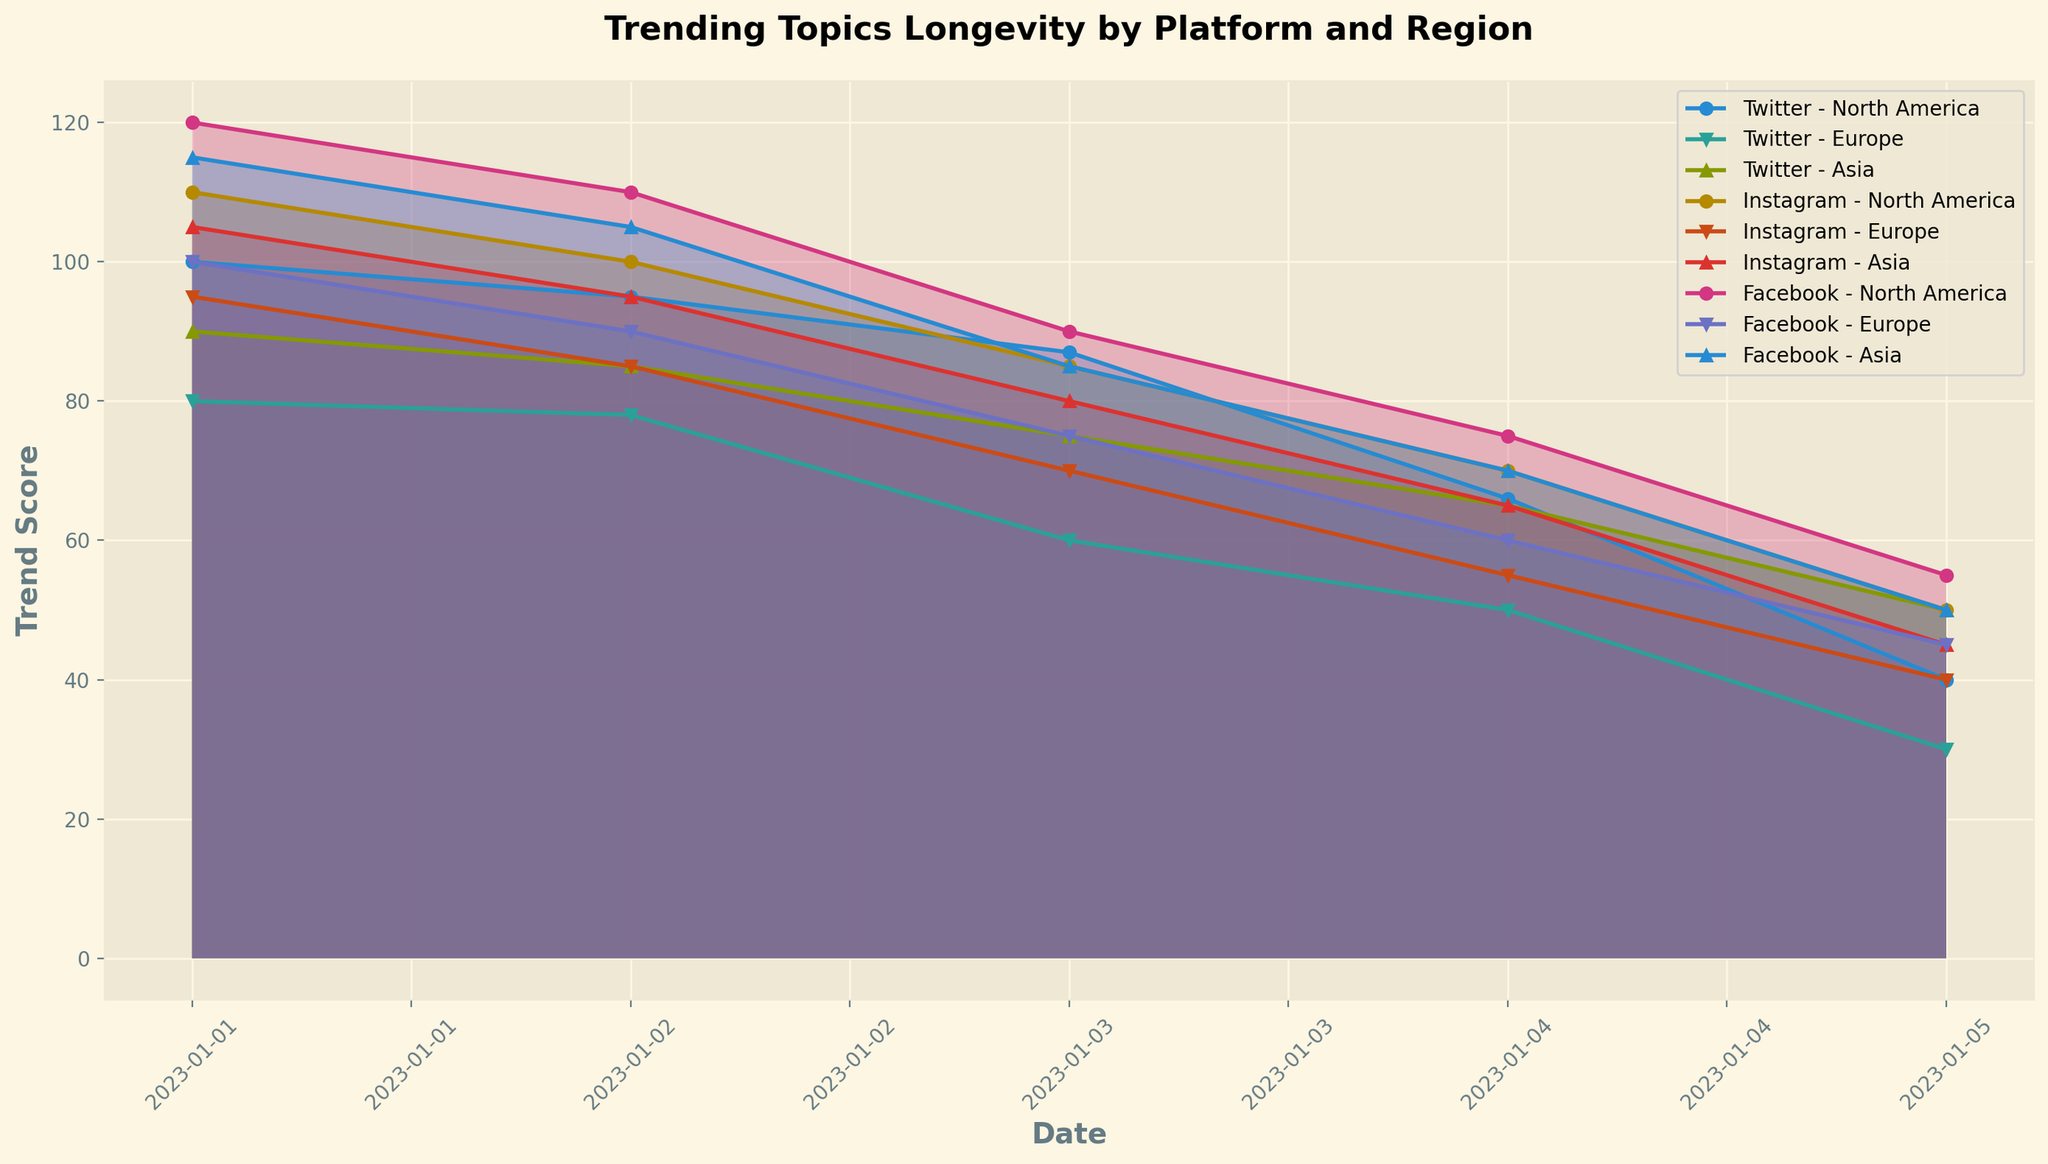What is the trend score for Topic A on Twitter in North America on 2023-01-03? Locate the line corresponding to Twitter in North America for Topic A and read off the trend score at the specified date.
Answer: 87 Which platform and region had the highest initial trend score for Topic C on 2023-01-01? Find the highest starting trend score for Topic C on 2023-01-01 by comparing the initial points across all platforms and regions.
Answer: Facebook in North America By how much did the trend score for Topic B on Instagram in Europe decrease between 2023-01-01 and 2023-01-05? Subtract the trend score of Instagram in Europe for Topic B on 2023-01-05 from the trend score on 2023-01-01.
Answer: 55 Which region experienced the steepest decline in trend score for Topic A on Twitter? Compare the slopes of the lines for each region for Topic A on Twitter to see which has the steepest decline from start to end.
Answer: North America What is the average trend score for Topic C on Facebook in Asia over the five days? Sum the trend scores for Topic C on Facebook in Asia over the five days and divide by 5.
Answer: 85 For Topic B on Instagram, which region had the slowest decline in trend score over the five days? Compare the overall decline in trend scores for Topic B on Instagram across all regions and identify the smallest decrease.
Answer: Europe Which topic on Facebook had a higher trend score on 2023-01-04 in North America: Topic C or Topic B? Compare the trend scores of Topic C and Topic B on Facebook in North America on 2023-01-04.
Answer: Topic C Overall, which platform appears to maintain higher trend scores for longer time periods? Visually compare the lines of best fit for each platform to see which has higher scores and less steep declines.
Answer: Facebook Between 2023-01-02 and 2023-01-03, did any platform in Asia have an increase in trend score for any topic? Check the lines representing platforms in Asia around the specified dates to see if any trend scores increased.
Answer: No Which platform and region had a trend score of 55 for any topic on 2023-01-04? Locate the point where the trend score is 55 on 2023-01-04 and identify the corresponding platform and region.
Answer: Facebook in North America 